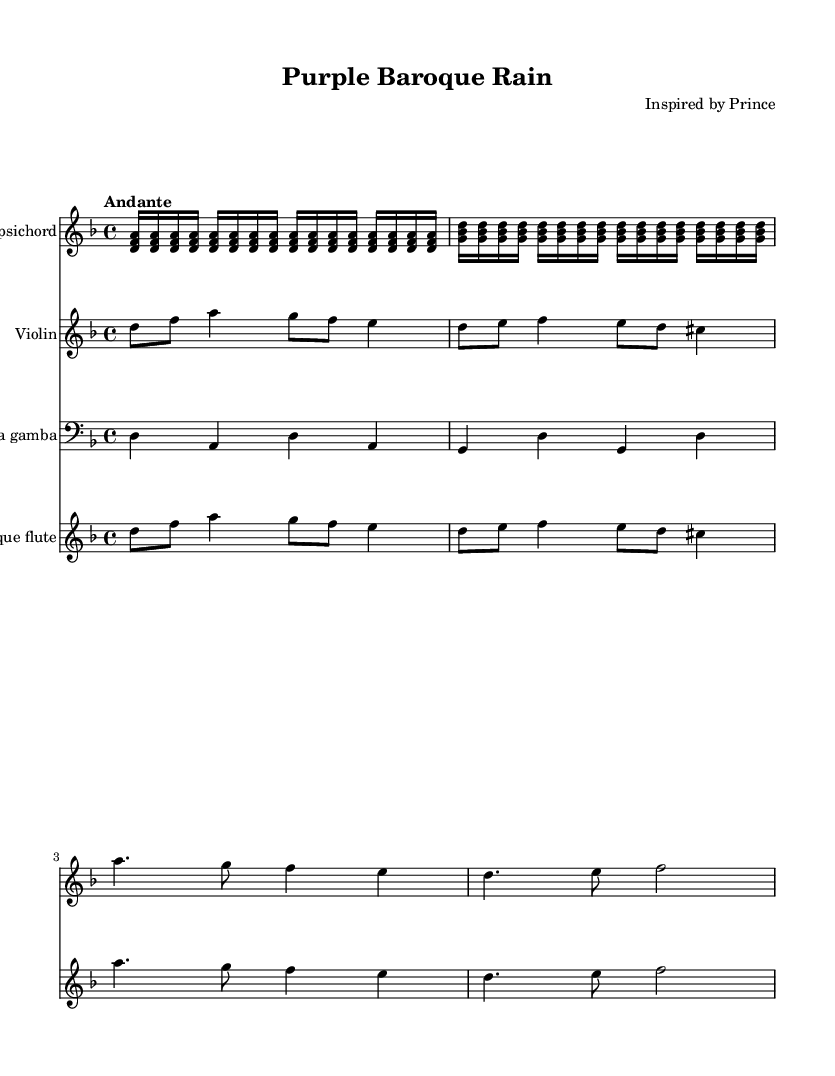What is the key signature of this music? The key signature shows two flats, indicating that it is in D minor.
Answer: D minor What is the time signature of this music? The time signature is indicated at the beginning of the sheet music as a fraction, which reads 4 over 4, representing four beats in a measure.
Answer: 4/4 What is the tempo marking of this piece? The tempo marking is indicated as "Andante," which means moderately slow and steady.
Answer: Andante How many instruments are indicated in the score? The score lists four distinct instruments, including Harpsichord, Violin, Viola da gamba, and Baroque flute.
Answer: Four Identify a type of extended instrumental technique that might be used by the violin in this piece. In the context of Baroque chamber music, techniques such as vibrato or double stops are commonly employed for expressive playing.
Answer: Vibrato What is the duration of the first harpsichord's repeated notes? The repeated notes in the harpsichord part are written as sixteenth notes, indicated by their shorter note stems in the score.
Answer: Sixteenth notes How is improvisation typically incorporated in Baroque chamber music? Baroque musicians often improvise embellishments, or ornamentations, based on the written melodic line, adding different techniques to enhance the performance.
Answer: Ornamentations 